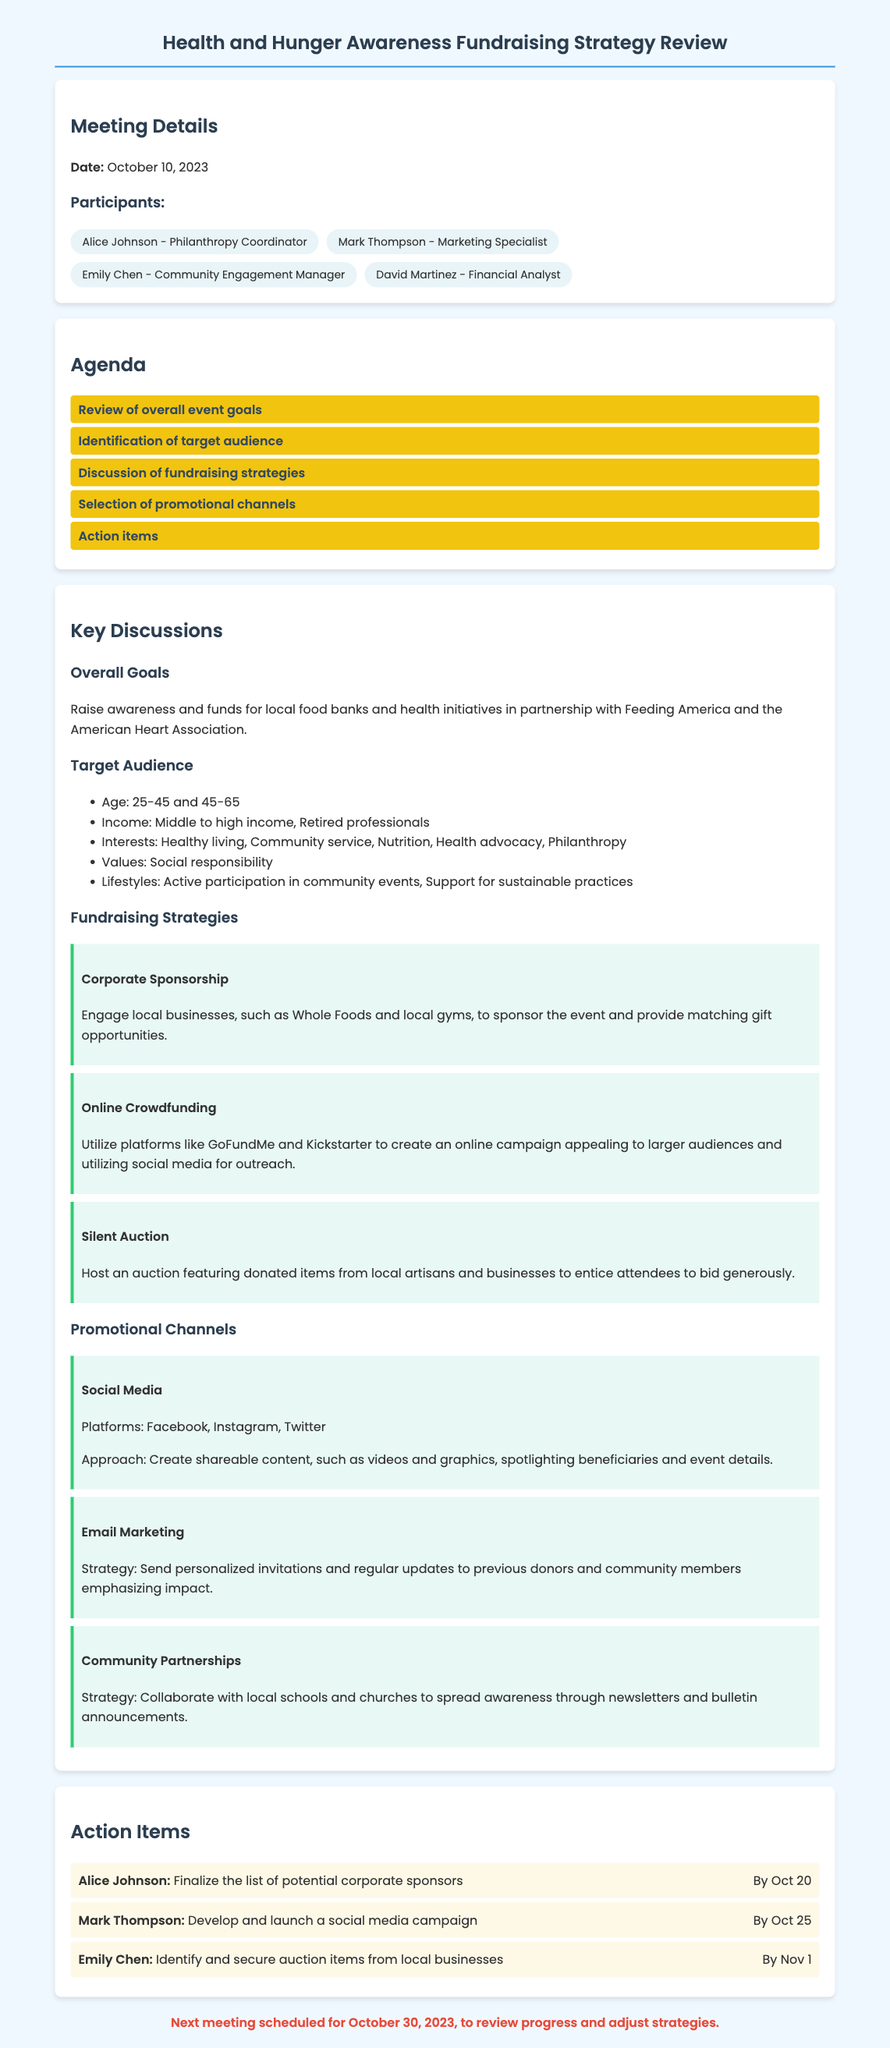what is the date of the meeting? The date of the meeting is mentioned in the document's meeting details section.
Answer: October 10, 2023 who is the philanthropy coordinator? The document lists participants, including their roles, specifically highlighting Alice Johnson's position.
Answer: Alice Johnson what age groups are included in the target audience? The target audience section outlines the specific age ranges targeted for the event.
Answer: 25-45 and 45-65 what is one fundraising strategy discussed? The fundraising strategies section lists various methods, and one can be directly referenced.
Answer: Corporate Sponsorship which platform is mentioned for online crowdfunding? The document specifies platforms that can be used for online fundraising campaigns within the fundraising strategies section.
Answer: GoFundMe how many action items are assigned? The action items are listed in a dedicated section, and counting them will reveal the total.
Answer: 3 what is the next meeting date? The next meeting date is clearly stated at the bottom of the meeting minutes.
Answer: October 30, 2023 which social media platforms are suggested for promotion? The promotional channels section mentions specific social media platforms to be utilized for outreach.
Answer: Facebook, Instagram, Twitter who is responsible for identifying auction items? The action items assign specific responsibilities to participants, indicating who is tasked with this duty.
Answer: Emily Chen 